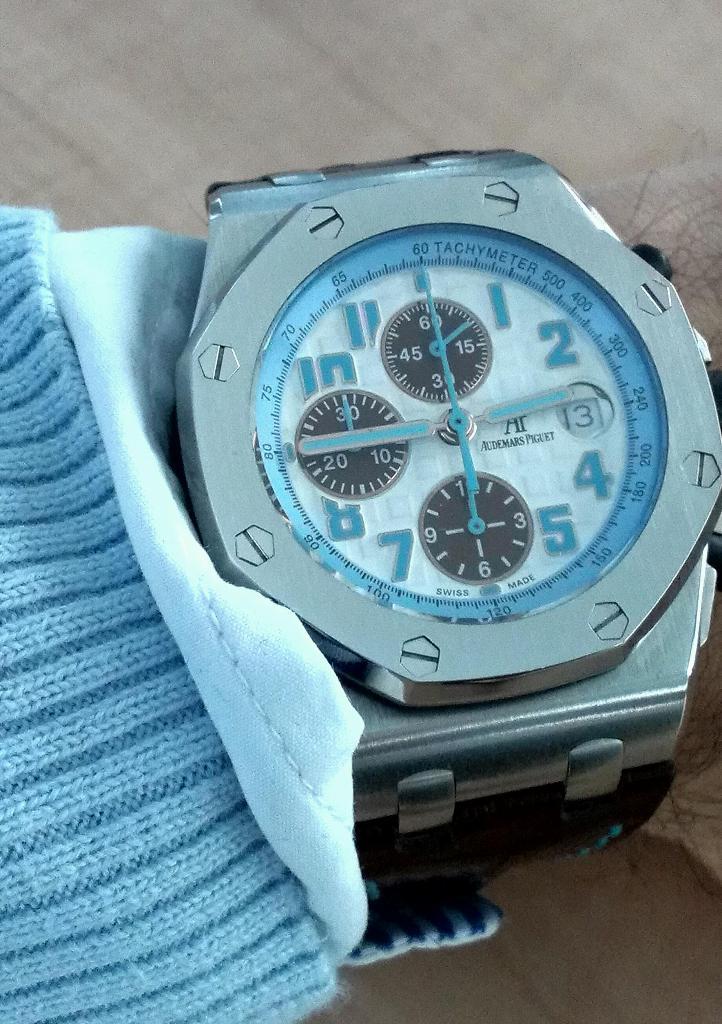What brand of watch is this?
Ensure brevity in your answer.  Unanswerable. What time is on the clock face?
Offer a terse response. 2:45. 